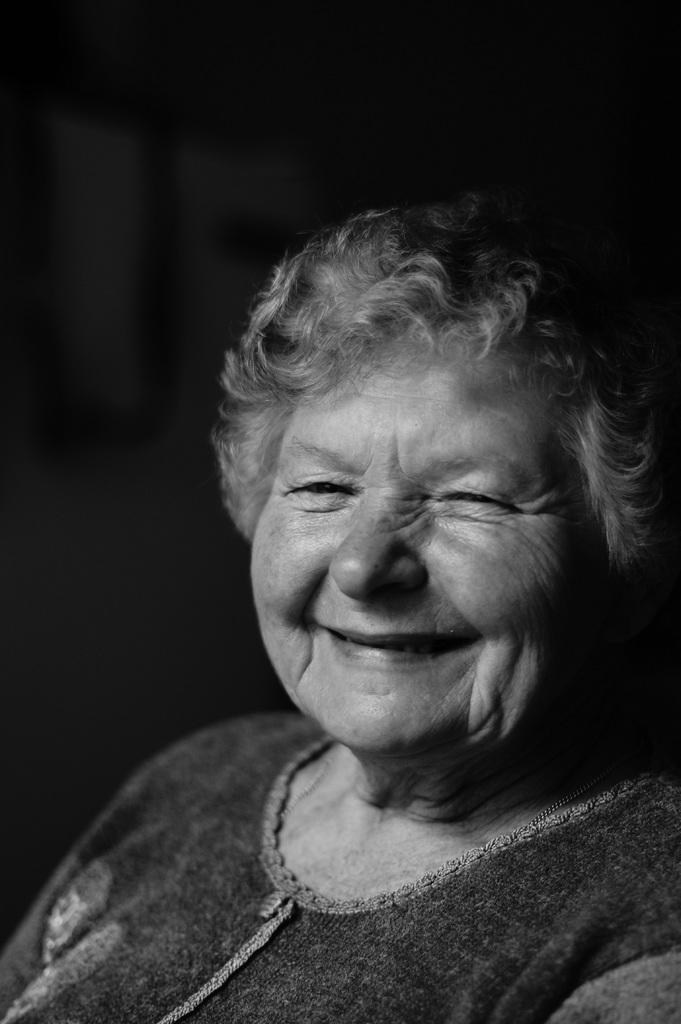What is the color scheme of the image? The image is black and white. Can you describe the person in the image? There is a lady in the image. What expression does the lady have? The lady is smiling. How many clovers can be seen in the lady's hand in the image? There are no clovers present in the image. What type of juice is the lady holding in the image? There is no juice present in the image. 